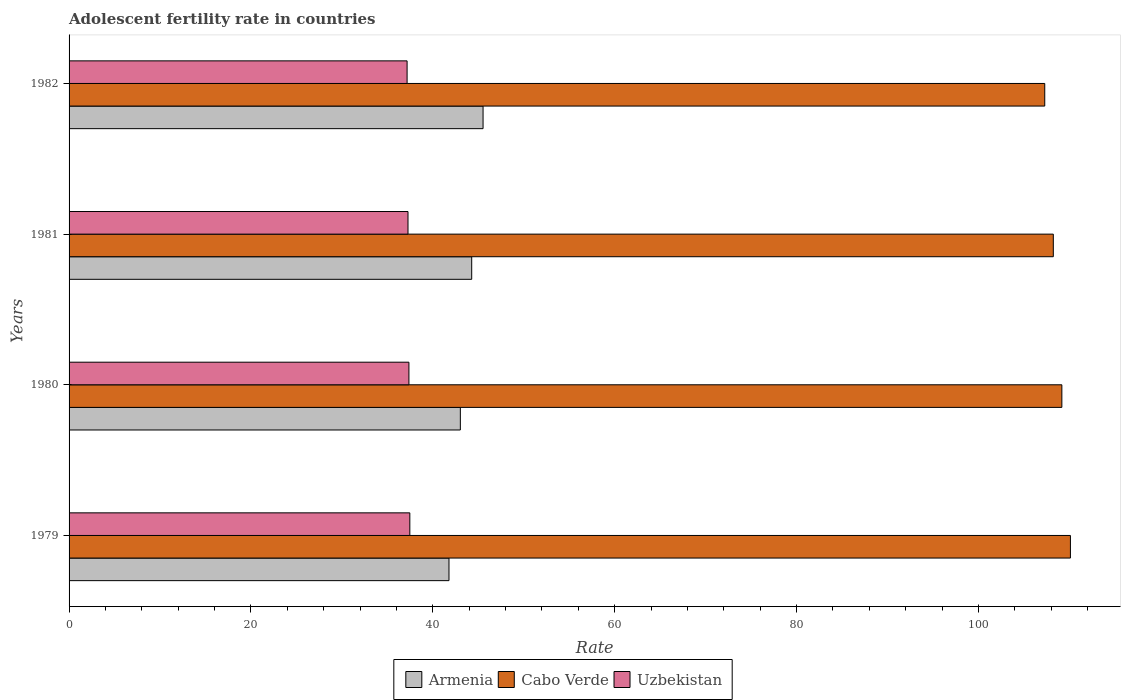Are the number of bars per tick equal to the number of legend labels?
Ensure brevity in your answer.  Yes. Are the number of bars on each tick of the Y-axis equal?
Offer a terse response. Yes. How many bars are there on the 4th tick from the bottom?
Ensure brevity in your answer.  3. What is the label of the 2nd group of bars from the top?
Keep it short and to the point. 1981. In how many cases, is the number of bars for a given year not equal to the number of legend labels?
Offer a very short reply. 0. What is the adolescent fertility rate in Cabo Verde in 1979?
Make the answer very short. 110.11. Across all years, what is the maximum adolescent fertility rate in Armenia?
Provide a short and direct response. 45.52. Across all years, what is the minimum adolescent fertility rate in Uzbekistan?
Your response must be concise. 37.17. In which year was the adolescent fertility rate in Uzbekistan maximum?
Offer a terse response. 1979. What is the total adolescent fertility rate in Armenia in the graph?
Keep it short and to the point. 174.6. What is the difference between the adolescent fertility rate in Armenia in 1980 and that in 1982?
Offer a very short reply. -2.5. What is the difference between the adolescent fertility rate in Armenia in 1980 and the adolescent fertility rate in Uzbekistan in 1979?
Ensure brevity in your answer.  5.55. What is the average adolescent fertility rate in Uzbekistan per year?
Make the answer very short. 37.32. In the year 1980, what is the difference between the adolescent fertility rate in Uzbekistan and adolescent fertility rate in Armenia?
Your answer should be compact. -5.65. In how many years, is the adolescent fertility rate in Uzbekistan greater than 80 ?
Offer a very short reply. 0. What is the ratio of the adolescent fertility rate in Uzbekistan in 1980 to that in 1982?
Your response must be concise. 1.01. Is the difference between the adolescent fertility rate in Uzbekistan in 1980 and 1982 greater than the difference between the adolescent fertility rate in Armenia in 1980 and 1982?
Your answer should be compact. Yes. What is the difference between the highest and the second highest adolescent fertility rate in Armenia?
Your response must be concise. 1.25. What is the difference between the highest and the lowest adolescent fertility rate in Armenia?
Your answer should be compact. 3.75. In how many years, is the adolescent fertility rate in Armenia greater than the average adolescent fertility rate in Armenia taken over all years?
Ensure brevity in your answer.  2. Is the sum of the adolescent fertility rate in Uzbekistan in 1980 and 1981 greater than the maximum adolescent fertility rate in Cabo Verde across all years?
Offer a terse response. No. What does the 1st bar from the top in 1979 represents?
Give a very brief answer. Uzbekistan. What does the 1st bar from the bottom in 1981 represents?
Offer a very short reply. Armenia. Is it the case that in every year, the sum of the adolescent fertility rate in Armenia and adolescent fertility rate in Uzbekistan is greater than the adolescent fertility rate in Cabo Verde?
Your answer should be compact. No. Are the values on the major ticks of X-axis written in scientific E-notation?
Give a very brief answer. No. How are the legend labels stacked?
Your answer should be very brief. Horizontal. What is the title of the graph?
Make the answer very short. Adolescent fertility rate in countries. What is the label or title of the X-axis?
Offer a terse response. Rate. What is the label or title of the Y-axis?
Your answer should be compact. Years. What is the Rate in Armenia in 1979?
Make the answer very short. 41.78. What is the Rate of Cabo Verde in 1979?
Make the answer very short. 110.11. What is the Rate of Uzbekistan in 1979?
Your response must be concise. 37.47. What is the Rate in Armenia in 1980?
Give a very brief answer. 43.03. What is the Rate of Cabo Verde in 1980?
Your response must be concise. 109.17. What is the Rate of Uzbekistan in 1980?
Ensure brevity in your answer.  37.37. What is the Rate of Armenia in 1981?
Provide a short and direct response. 44.27. What is the Rate of Cabo Verde in 1981?
Your answer should be compact. 108.23. What is the Rate in Uzbekistan in 1981?
Keep it short and to the point. 37.27. What is the Rate in Armenia in 1982?
Provide a succinct answer. 45.52. What is the Rate of Cabo Verde in 1982?
Provide a short and direct response. 107.29. What is the Rate of Uzbekistan in 1982?
Your response must be concise. 37.17. Across all years, what is the maximum Rate in Armenia?
Make the answer very short. 45.52. Across all years, what is the maximum Rate of Cabo Verde?
Provide a short and direct response. 110.11. Across all years, what is the maximum Rate of Uzbekistan?
Provide a succinct answer. 37.47. Across all years, what is the minimum Rate in Armenia?
Your answer should be very brief. 41.78. Across all years, what is the minimum Rate in Cabo Verde?
Your response must be concise. 107.29. Across all years, what is the minimum Rate in Uzbekistan?
Offer a terse response. 37.17. What is the total Rate of Armenia in the graph?
Keep it short and to the point. 174.6. What is the total Rate of Cabo Verde in the graph?
Give a very brief answer. 434.8. What is the total Rate in Uzbekistan in the graph?
Make the answer very short. 149.28. What is the difference between the Rate in Armenia in 1979 and that in 1980?
Your response must be concise. -1.25. What is the difference between the Rate in Cabo Verde in 1979 and that in 1980?
Ensure brevity in your answer.  0.94. What is the difference between the Rate of Uzbekistan in 1979 and that in 1980?
Offer a terse response. 0.1. What is the difference between the Rate in Armenia in 1979 and that in 1981?
Keep it short and to the point. -2.5. What is the difference between the Rate in Cabo Verde in 1979 and that in 1981?
Offer a very short reply. 1.88. What is the difference between the Rate in Uzbekistan in 1979 and that in 1981?
Your answer should be compact. 0.2. What is the difference between the Rate in Armenia in 1979 and that in 1982?
Give a very brief answer. -3.75. What is the difference between the Rate in Cabo Verde in 1979 and that in 1982?
Offer a very short reply. 2.82. What is the difference between the Rate in Uzbekistan in 1979 and that in 1982?
Provide a short and direct response. 0.3. What is the difference between the Rate in Armenia in 1980 and that in 1981?
Offer a terse response. -1.25. What is the difference between the Rate of Cabo Verde in 1980 and that in 1981?
Your response must be concise. 0.94. What is the difference between the Rate of Uzbekistan in 1980 and that in 1981?
Make the answer very short. 0.1. What is the difference between the Rate of Armenia in 1980 and that in 1982?
Your answer should be compact. -2.5. What is the difference between the Rate of Cabo Verde in 1980 and that in 1982?
Give a very brief answer. 1.88. What is the difference between the Rate in Uzbekistan in 1980 and that in 1982?
Give a very brief answer. 0.2. What is the difference between the Rate in Armenia in 1981 and that in 1982?
Offer a very short reply. -1.25. What is the difference between the Rate in Cabo Verde in 1981 and that in 1982?
Your response must be concise. 0.94. What is the difference between the Rate of Uzbekistan in 1981 and that in 1982?
Your answer should be compact. 0.1. What is the difference between the Rate in Armenia in 1979 and the Rate in Cabo Verde in 1980?
Make the answer very short. -67.39. What is the difference between the Rate of Armenia in 1979 and the Rate of Uzbekistan in 1980?
Provide a short and direct response. 4.41. What is the difference between the Rate in Cabo Verde in 1979 and the Rate in Uzbekistan in 1980?
Provide a short and direct response. 72.74. What is the difference between the Rate in Armenia in 1979 and the Rate in Cabo Verde in 1981?
Provide a short and direct response. -66.45. What is the difference between the Rate in Armenia in 1979 and the Rate in Uzbekistan in 1981?
Keep it short and to the point. 4.51. What is the difference between the Rate of Cabo Verde in 1979 and the Rate of Uzbekistan in 1981?
Make the answer very short. 72.84. What is the difference between the Rate of Armenia in 1979 and the Rate of Cabo Verde in 1982?
Your response must be concise. -65.51. What is the difference between the Rate in Armenia in 1979 and the Rate in Uzbekistan in 1982?
Offer a terse response. 4.61. What is the difference between the Rate in Cabo Verde in 1979 and the Rate in Uzbekistan in 1982?
Your answer should be very brief. 72.94. What is the difference between the Rate in Armenia in 1980 and the Rate in Cabo Verde in 1981?
Offer a very short reply. -65.2. What is the difference between the Rate in Armenia in 1980 and the Rate in Uzbekistan in 1981?
Give a very brief answer. 5.75. What is the difference between the Rate of Cabo Verde in 1980 and the Rate of Uzbekistan in 1981?
Offer a very short reply. 71.9. What is the difference between the Rate in Armenia in 1980 and the Rate in Cabo Verde in 1982?
Offer a terse response. -64.26. What is the difference between the Rate of Armenia in 1980 and the Rate of Uzbekistan in 1982?
Give a very brief answer. 5.86. What is the difference between the Rate in Cabo Verde in 1980 and the Rate in Uzbekistan in 1982?
Make the answer very short. 72. What is the difference between the Rate of Armenia in 1981 and the Rate of Cabo Verde in 1982?
Offer a terse response. -63.01. What is the difference between the Rate of Armenia in 1981 and the Rate of Uzbekistan in 1982?
Make the answer very short. 7.1. What is the difference between the Rate of Cabo Verde in 1981 and the Rate of Uzbekistan in 1982?
Ensure brevity in your answer.  71.06. What is the average Rate of Armenia per year?
Offer a terse response. 43.65. What is the average Rate in Cabo Verde per year?
Offer a terse response. 108.7. What is the average Rate of Uzbekistan per year?
Make the answer very short. 37.32. In the year 1979, what is the difference between the Rate in Armenia and Rate in Cabo Verde?
Provide a succinct answer. -68.34. In the year 1979, what is the difference between the Rate in Armenia and Rate in Uzbekistan?
Make the answer very short. 4.31. In the year 1979, what is the difference between the Rate of Cabo Verde and Rate of Uzbekistan?
Keep it short and to the point. 72.64. In the year 1980, what is the difference between the Rate of Armenia and Rate of Cabo Verde?
Your answer should be compact. -66.14. In the year 1980, what is the difference between the Rate of Armenia and Rate of Uzbekistan?
Your answer should be very brief. 5.65. In the year 1980, what is the difference between the Rate in Cabo Verde and Rate in Uzbekistan?
Your answer should be compact. 71.8. In the year 1981, what is the difference between the Rate of Armenia and Rate of Cabo Verde?
Give a very brief answer. -63.95. In the year 1981, what is the difference between the Rate in Armenia and Rate in Uzbekistan?
Your answer should be compact. 7. In the year 1981, what is the difference between the Rate of Cabo Verde and Rate of Uzbekistan?
Your answer should be compact. 70.96. In the year 1982, what is the difference between the Rate of Armenia and Rate of Cabo Verde?
Your response must be concise. -61.76. In the year 1982, what is the difference between the Rate in Armenia and Rate in Uzbekistan?
Offer a terse response. 8.35. In the year 1982, what is the difference between the Rate in Cabo Verde and Rate in Uzbekistan?
Provide a short and direct response. 70.12. What is the ratio of the Rate in Cabo Verde in 1979 to that in 1980?
Offer a terse response. 1.01. What is the ratio of the Rate of Armenia in 1979 to that in 1981?
Provide a succinct answer. 0.94. What is the ratio of the Rate of Cabo Verde in 1979 to that in 1981?
Your answer should be compact. 1.02. What is the ratio of the Rate of Uzbekistan in 1979 to that in 1981?
Offer a terse response. 1.01. What is the ratio of the Rate in Armenia in 1979 to that in 1982?
Keep it short and to the point. 0.92. What is the ratio of the Rate in Cabo Verde in 1979 to that in 1982?
Your answer should be very brief. 1.03. What is the ratio of the Rate in Armenia in 1980 to that in 1981?
Ensure brevity in your answer.  0.97. What is the ratio of the Rate in Cabo Verde in 1980 to that in 1981?
Make the answer very short. 1.01. What is the ratio of the Rate in Uzbekistan in 1980 to that in 1981?
Make the answer very short. 1. What is the ratio of the Rate of Armenia in 1980 to that in 1982?
Keep it short and to the point. 0.95. What is the ratio of the Rate in Cabo Verde in 1980 to that in 1982?
Your response must be concise. 1.02. What is the ratio of the Rate of Uzbekistan in 1980 to that in 1982?
Make the answer very short. 1.01. What is the ratio of the Rate in Armenia in 1981 to that in 1982?
Your response must be concise. 0.97. What is the ratio of the Rate of Cabo Verde in 1981 to that in 1982?
Provide a succinct answer. 1.01. What is the difference between the highest and the second highest Rate in Armenia?
Offer a terse response. 1.25. What is the difference between the highest and the second highest Rate of Cabo Verde?
Offer a terse response. 0.94. What is the difference between the highest and the second highest Rate in Uzbekistan?
Your answer should be compact. 0.1. What is the difference between the highest and the lowest Rate in Armenia?
Offer a terse response. 3.75. What is the difference between the highest and the lowest Rate in Cabo Verde?
Your answer should be compact. 2.82. What is the difference between the highest and the lowest Rate in Uzbekistan?
Provide a succinct answer. 0.3. 